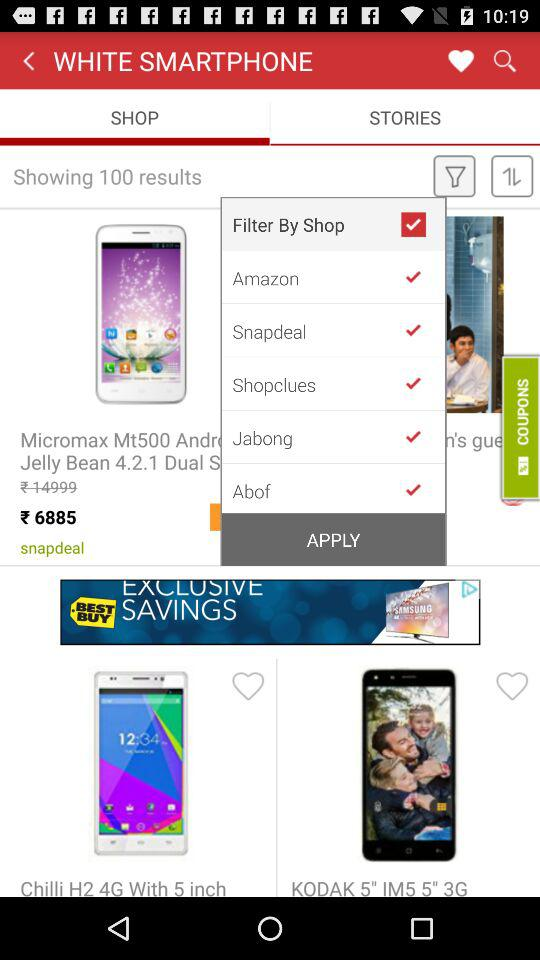How many results are there? There are 100 results. 